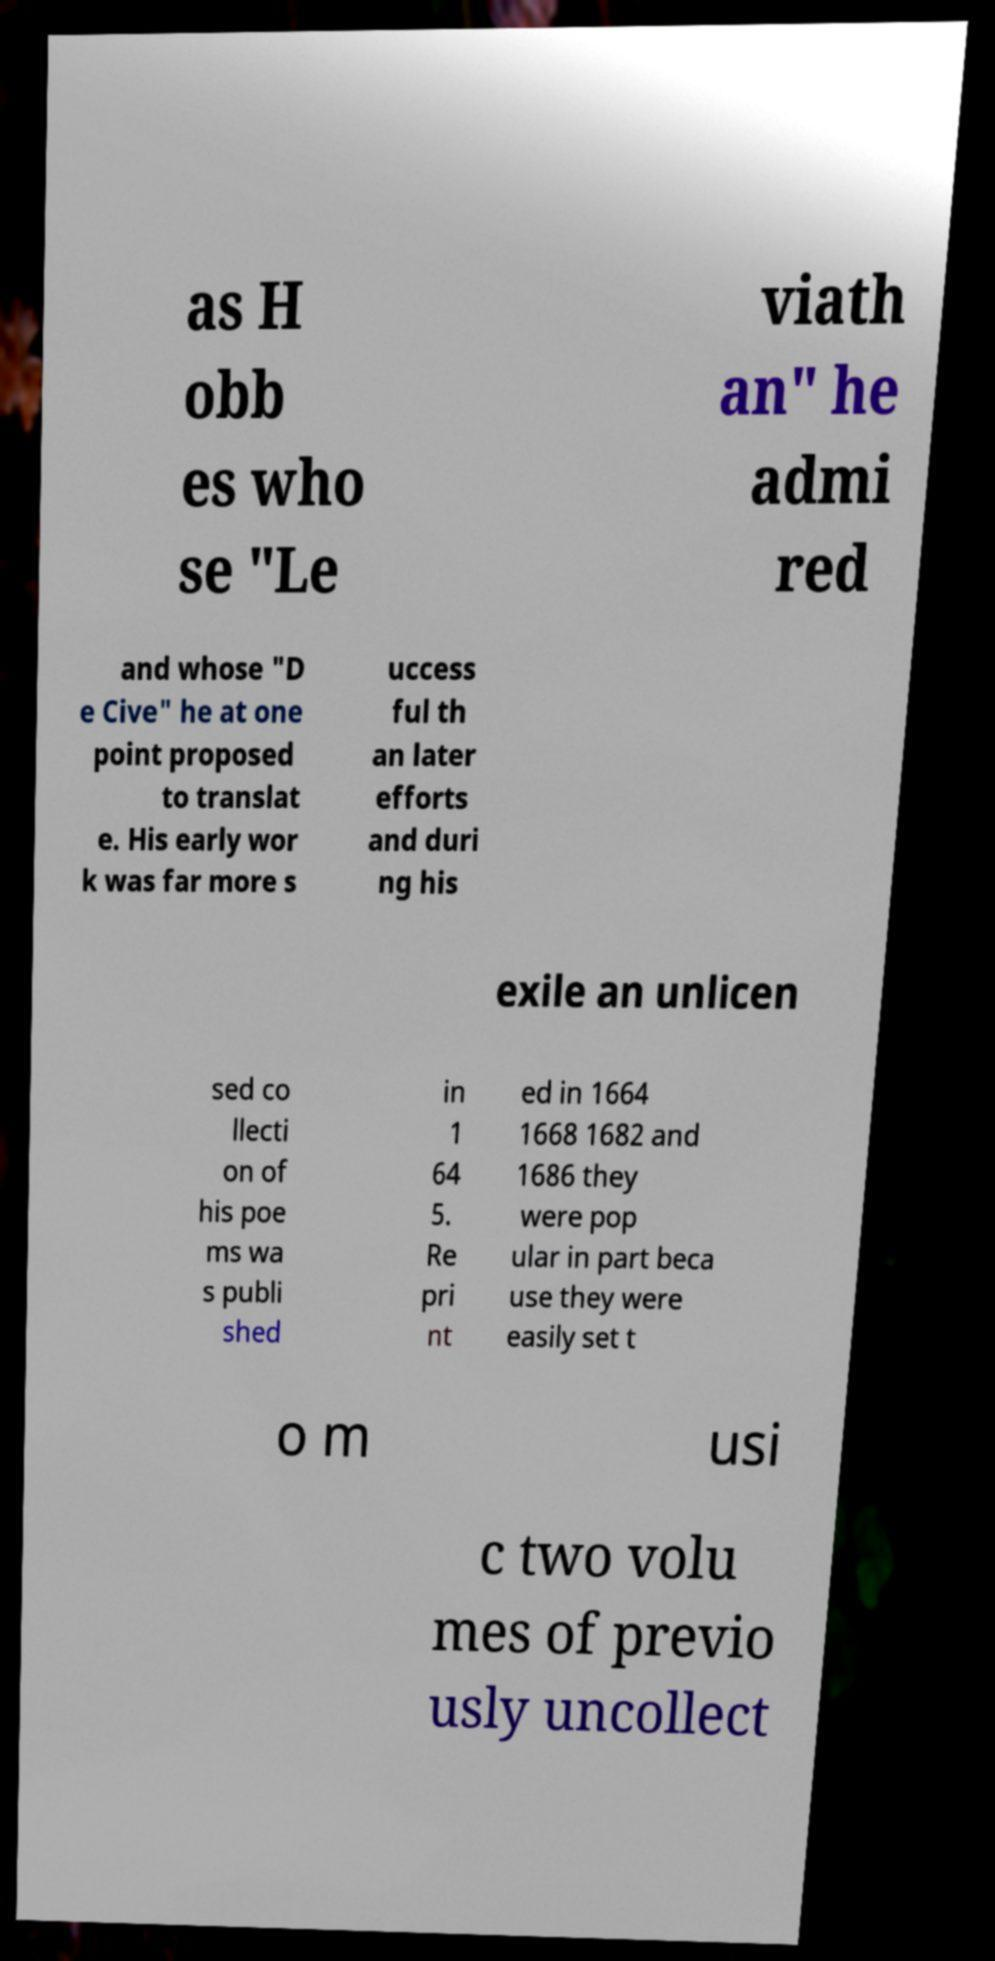Could you assist in decoding the text presented in this image and type it out clearly? as H obb es who se "Le viath an" he admi red and whose "D e Cive" he at one point proposed to translat e. His early wor k was far more s uccess ful th an later efforts and duri ng his exile an unlicen sed co llecti on of his poe ms wa s publi shed in 1 64 5. Re pri nt ed in 1664 1668 1682 and 1686 they were pop ular in part beca use they were easily set t o m usi c two volu mes of previo usly uncollect 